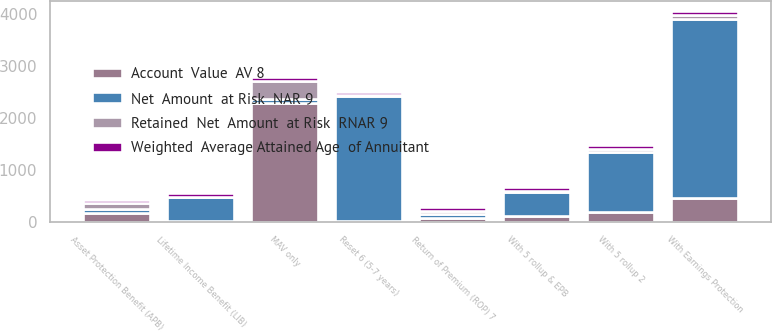Convert chart to OTSL. <chart><loc_0><loc_0><loc_500><loc_500><stacked_bar_chart><ecel><fcel>MAV only<fcel>With 5 rollup 2<fcel>With Earnings Protection<fcel>With 5 rollup & EPB<fcel>Asset Protection Benefit (APB)<fcel>Lifetime Income Benefit (LIB)<fcel>Reset 6 (5-7 years)<fcel>Return of Premium (ROP) 7<nl><fcel>Net  Amount  at Risk  NAR 9<fcel>71<fcel>1156<fcel>3436<fcel>467<fcel>71<fcel>464<fcel>2406<fcel>71<nl><fcel>Account  Value  AV 8<fcel>2285<fcel>187<fcel>464<fcel>102<fcel>172<fcel>6<fcel>13<fcel>69<nl><fcel>Retained  Net  Amount  at Risk  RNAR 9<fcel>350<fcel>60<fcel>75<fcel>22<fcel>114<fcel>6<fcel>12<fcel>65<nl><fcel>Weighted  Average Attained Age  of Annuitant<fcel>71<fcel>71<fcel>70<fcel>73<fcel>69<fcel>70<fcel>70<fcel>69<nl></chart> 